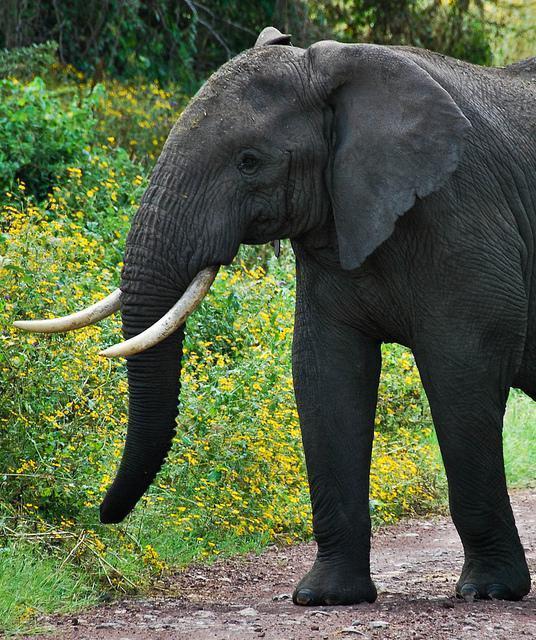How many elephants are visible?
Give a very brief answer. 1. How many people do you see?
Give a very brief answer. 0. 